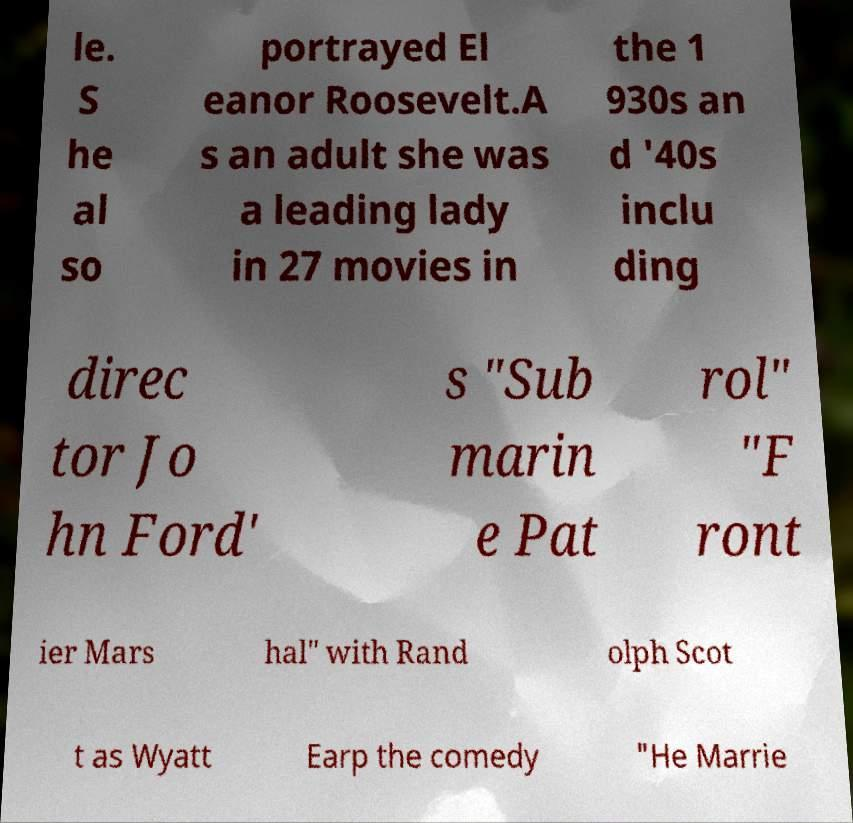There's text embedded in this image that I need extracted. Can you transcribe it verbatim? le. S he al so portrayed El eanor Roosevelt.A s an adult she was a leading lady in 27 movies in the 1 930s an d '40s inclu ding direc tor Jo hn Ford' s "Sub marin e Pat rol" "F ront ier Mars hal" with Rand olph Scot t as Wyatt Earp the comedy "He Marrie 